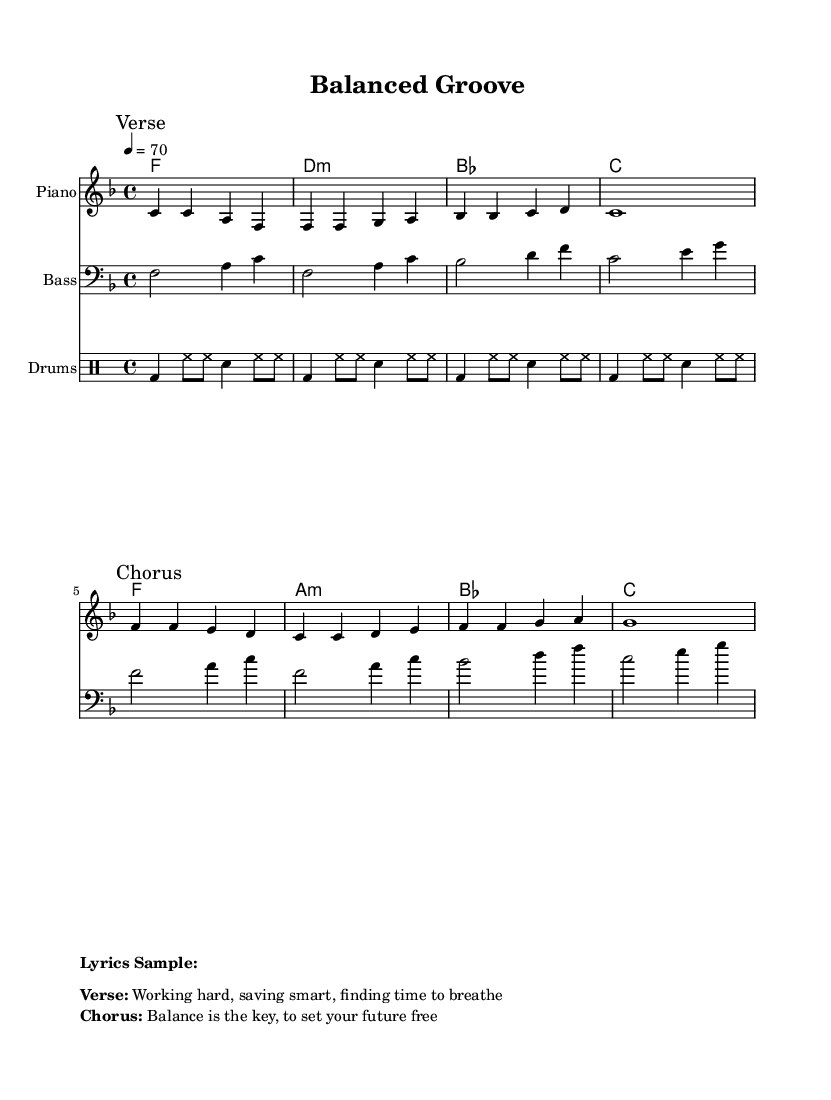What is the key signature of this music? The key signature is F major, which has one flat (B flat).
Answer: F major What is the time signature of the piece? The time signature is 4/4, indicating four beats per measure.
Answer: 4/4 What is the tempo marking for this piece? The tempo marking is 4 = 70, which indicates the speed at which to play the music.
Answer: 70 What is the first note in the melody? The first note in the melody is C, as indicated at the beginning of the melody section.
Answer: C How many measures are in the chorus section? The chorus section consists of four measures, which can be counted from the first note of the chorus to the end of the last chord.
Answer: 4 What type of drums are indicated in this score? The types of drums indicated include bass drum, hi-hat, and snare. These specific notations in the drum staff reveal the drum kit components used.
Answer: Bass drum, hi-hat, snare What is the lyrical theme of the verse? The lyrical theme of the verse reflects on the concepts of hard work and finding time to breathe in balance with life.
Answer: Working hard, saving smart, finding time to breathe 